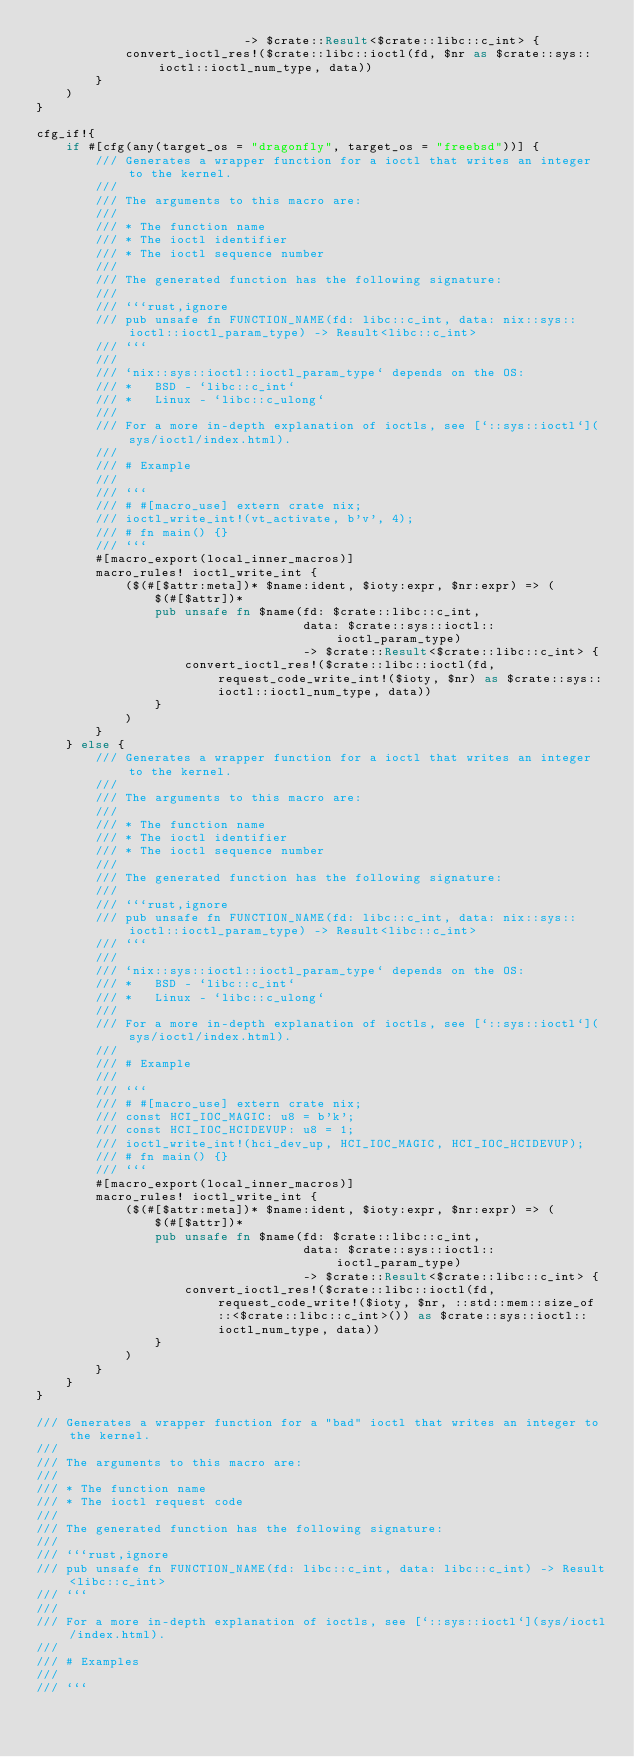Convert code to text. <code><loc_0><loc_0><loc_500><loc_500><_Rust_>                            -> $crate::Result<$crate::libc::c_int> {
            convert_ioctl_res!($crate::libc::ioctl(fd, $nr as $crate::sys::ioctl::ioctl_num_type, data))
        }
    )
}

cfg_if!{
    if #[cfg(any(target_os = "dragonfly", target_os = "freebsd"))] {
        /// Generates a wrapper function for a ioctl that writes an integer to the kernel.
        ///
        /// The arguments to this macro are:
        ///
        /// * The function name
        /// * The ioctl identifier
        /// * The ioctl sequence number
        ///
        /// The generated function has the following signature:
        ///
        /// ```rust,ignore
        /// pub unsafe fn FUNCTION_NAME(fd: libc::c_int, data: nix::sys::ioctl::ioctl_param_type) -> Result<libc::c_int>
        /// ```
        ///
        /// `nix::sys::ioctl::ioctl_param_type` depends on the OS:
        /// *   BSD - `libc::c_int`
        /// *   Linux - `libc::c_ulong`
        ///
        /// For a more in-depth explanation of ioctls, see [`::sys::ioctl`](sys/ioctl/index.html).
        ///
        /// # Example
        ///
        /// ```
        /// # #[macro_use] extern crate nix;
        /// ioctl_write_int!(vt_activate, b'v', 4);
        /// # fn main() {}
        /// ```
        #[macro_export(local_inner_macros)]
        macro_rules! ioctl_write_int {
            ($(#[$attr:meta])* $name:ident, $ioty:expr, $nr:expr) => (
                $(#[$attr])*
                pub unsafe fn $name(fd: $crate::libc::c_int,
                                    data: $crate::sys::ioctl::ioctl_param_type)
                                    -> $crate::Result<$crate::libc::c_int> {
                    convert_ioctl_res!($crate::libc::ioctl(fd, request_code_write_int!($ioty, $nr) as $crate::sys::ioctl::ioctl_num_type, data))
                }
            )
        }
    } else {
        /// Generates a wrapper function for a ioctl that writes an integer to the kernel.
        ///
        /// The arguments to this macro are:
        ///
        /// * The function name
        /// * The ioctl identifier
        /// * The ioctl sequence number
        ///
        /// The generated function has the following signature:
        ///
        /// ```rust,ignore
        /// pub unsafe fn FUNCTION_NAME(fd: libc::c_int, data: nix::sys::ioctl::ioctl_param_type) -> Result<libc::c_int>
        /// ```
        ///
        /// `nix::sys::ioctl::ioctl_param_type` depends on the OS:
        /// *   BSD - `libc::c_int`
        /// *   Linux - `libc::c_ulong`
        ///
        /// For a more in-depth explanation of ioctls, see [`::sys::ioctl`](sys/ioctl/index.html).
        ///
        /// # Example
        ///
        /// ```
        /// # #[macro_use] extern crate nix;
        /// const HCI_IOC_MAGIC: u8 = b'k';
        /// const HCI_IOC_HCIDEVUP: u8 = 1;
        /// ioctl_write_int!(hci_dev_up, HCI_IOC_MAGIC, HCI_IOC_HCIDEVUP);
        /// # fn main() {}
        /// ```
        #[macro_export(local_inner_macros)]
        macro_rules! ioctl_write_int {
            ($(#[$attr:meta])* $name:ident, $ioty:expr, $nr:expr) => (
                $(#[$attr])*
                pub unsafe fn $name(fd: $crate::libc::c_int,
                                    data: $crate::sys::ioctl::ioctl_param_type)
                                    -> $crate::Result<$crate::libc::c_int> {
                    convert_ioctl_res!($crate::libc::ioctl(fd, request_code_write!($ioty, $nr, ::std::mem::size_of::<$crate::libc::c_int>()) as $crate::sys::ioctl::ioctl_num_type, data))
                }
            )
        }
    }
}

/// Generates a wrapper function for a "bad" ioctl that writes an integer to the kernel.
///
/// The arguments to this macro are:
///
/// * The function name
/// * The ioctl request code
///
/// The generated function has the following signature:
///
/// ```rust,ignore
/// pub unsafe fn FUNCTION_NAME(fd: libc::c_int, data: libc::c_int) -> Result<libc::c_int>
/// ```
///
/// For a more in-depth explanation of ioctls, see [`::sys::ioctl`](sys/ioctl/index.html).
///
/// # Examples
///
/// ```</code> 